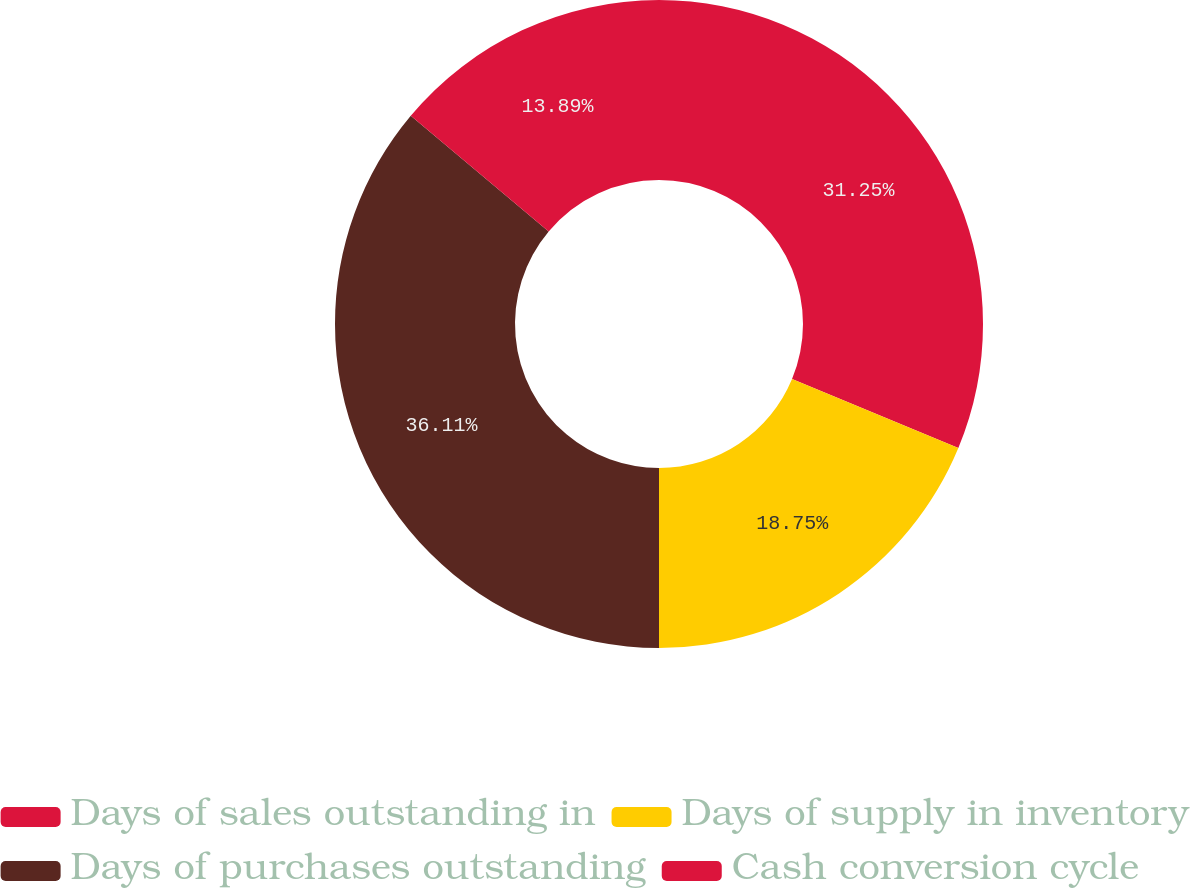Convert chart to OTSL. <chart><loc_0><loc_0><loc_500><loc_500><pie_chart><fcel>Days of sales outstanding in<fcel>Days of supply in inventory<fcel>Days of purchases outstanding<fcel>Cash conversion cycle<nl><fcel>31.25%<fcel>18.75%<fcel>36.11%<fcel>13.89%<nl></chart> 